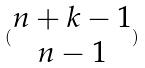Convert formula to latex. <formula><loc_0><loc_0><loc_500><loc_500>( \begin{matrix} n + k - 1 \\ n - 1 \end{matrix} )</formula> 